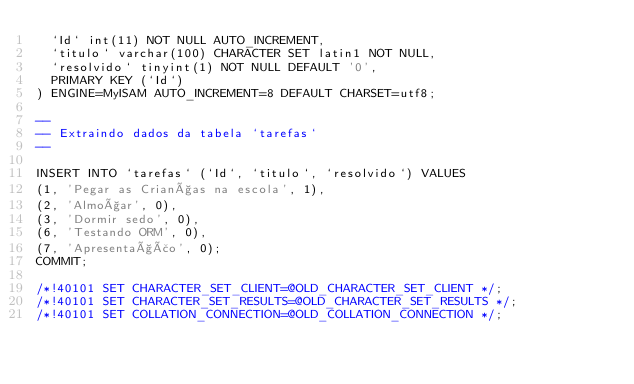<code> <loc_0><loc_0><loc_500><loc_500><_SQL_>  `Id` int(11) NOT NULL AUTO_INCREMENT,
  `titulo` varchar(100) CHARACTER SET latin1 NOT NULL,
  `resolvido` tinyint(1) NOT NULL DEFAULT '0',
  PRIMARY KEY (`Id`)
) ENGINE=MyISAM AUTO_INCREMENT=8 DEFAULT CHARSET=utf8;

--
-- Extraindo dados da tabela `tarefas`
--

INSERT INTO `tarefas` (`Id`, `titulo`, `resolvido`) VALUES
(1, 'Pegar as Crianças na escola', 1),
(2, 'Almoçar', 0),
(3, 'Dormir sedo', 0),
(6, 'Testando ORM', 0),
(7, 'Apresentação', 0);
COMMIT;

/*!40101 SET CHARACTER_SET_CLIENT=@OLD_CHARACTER_SET_CLIENT */;
/*!40101 SET CHARACTER_SET_RESULTS=@OLD_CHARACTER_SET_RESULTS */;
/*!40101 SET COLLATION_CONNECTION=@OLD_COLLATION_CONNECTION */;
</code> 